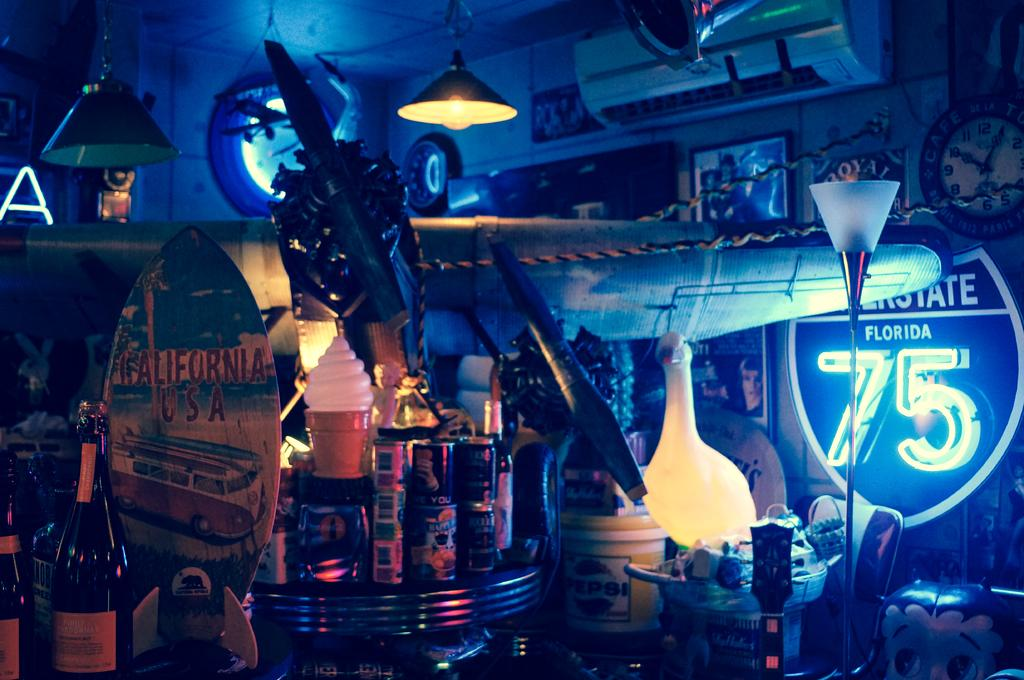<image>
Summarize the visual content of the image. Many knick knacks are in a room, including a Florida highway sign. 